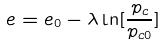<formula> <loc_0><loc_0><loc_500><loc_500>e = e _ { 0 } - \lambda \ln [ \frac { p _ { c } } { p _ { c 0 } } ]</formula> 